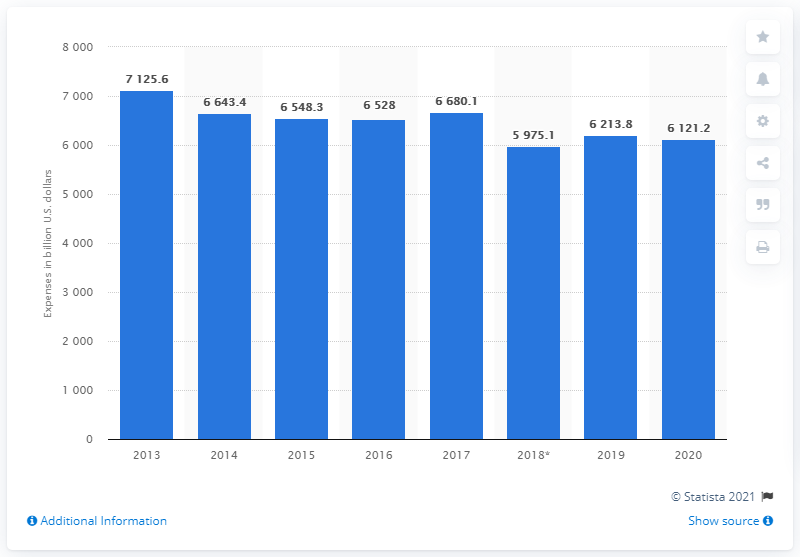Point out several critical features in this image. Eli Lilly's expenses in 2020 were approximately $61,212.20. 